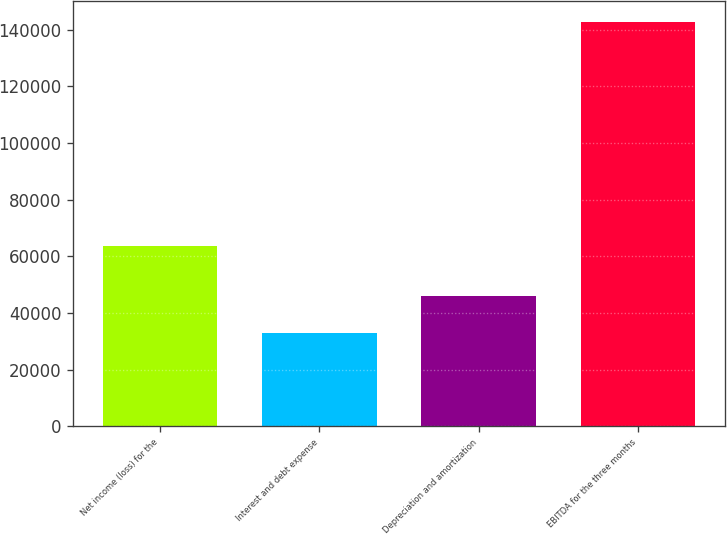<chart> <loc_0><loc_0><loc_500><loc_500><bar_chart><fcel>Net income (loss) for the<fcel>Interest and debt expense<fcel>Depreciation and amortization<fcel>EBITDA for the three months<nl><fcel>63813<fcel>32979<fcel>46113<fcel>142905<nl></chart> 